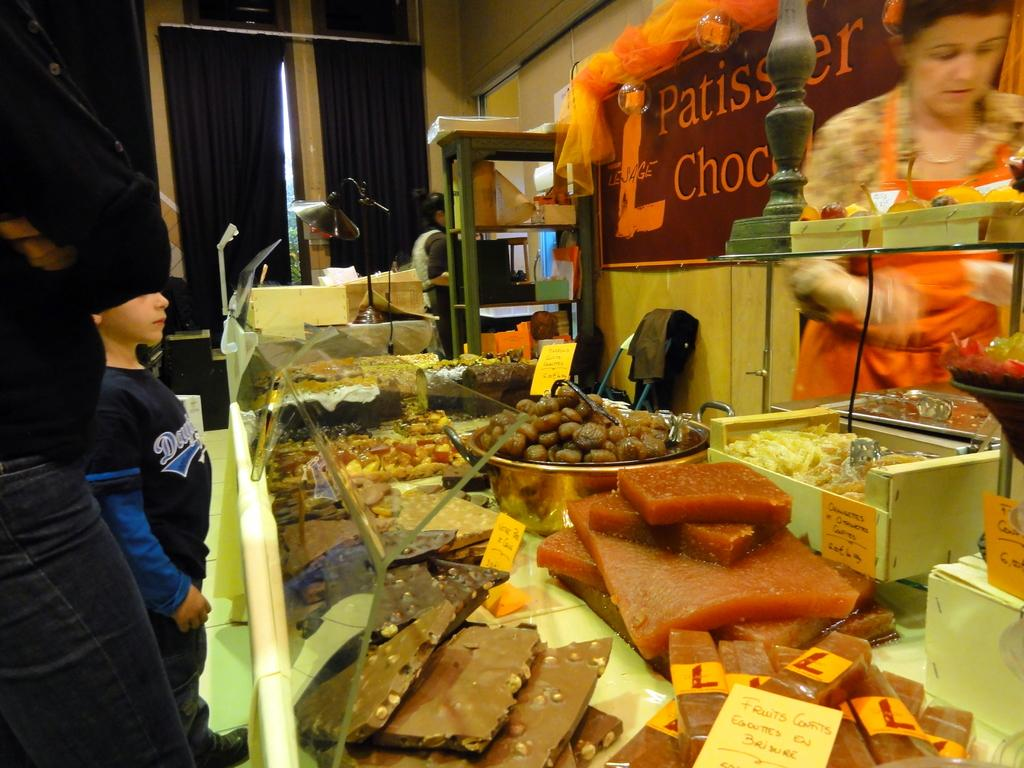<image>
Provide a brief description of the given image. Patissery sign behind a bunch of food on a counter. 